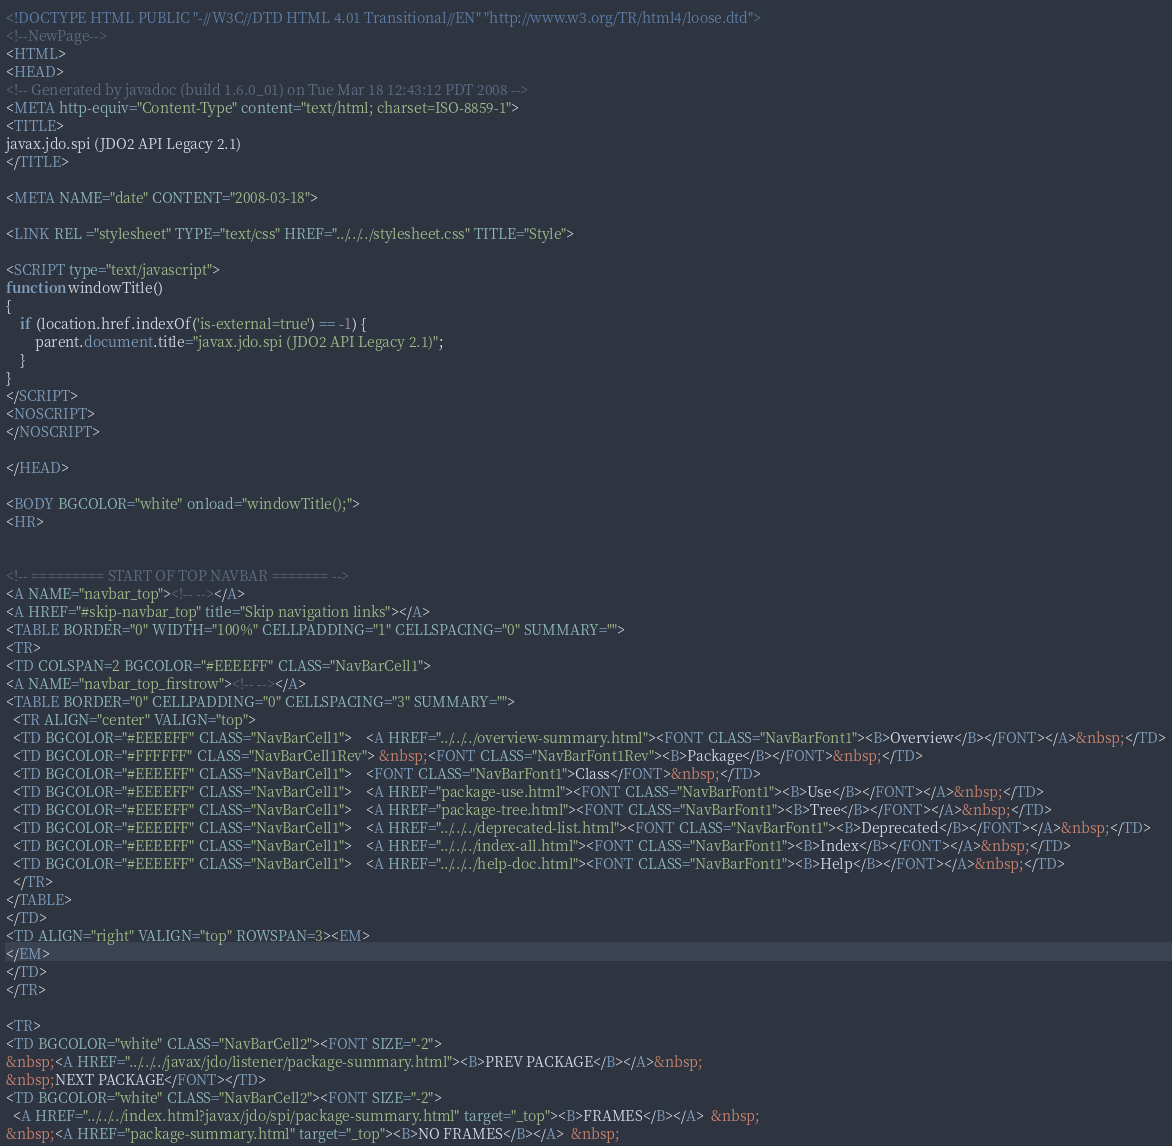Convert code to text. <code><loc_0><loc_0><loc_500><loc_500><_HTML_><!DOCTYPE HTML PUBLIC "-//W3C//DTD HTML 4.01 Transitional//EN" "http://www.w3.org/TR/html4/loose.dtd">
<!--NewPage-->
<HTML>
<HEAD>
<!-- Generated by javadoc (build 1.6.0_01) on Tue Mar 18 12:43:12 PDT 2008 -->
<META http-equiv="Content-Type" content="text/html; charset=ISO-8859-1">
<TITLE>
javax.jdo.spi (JDO2 API Legacy 2.1)
</TITLE>

<META NAME="date" CONTENT="2008-03-18">

<LINK REL ="stylesheet" TYPE="text/css" HREF="../../../stylesheet.css" TITLE="Style">

<SCRIPT type="text/javascript">
function windowTitle()
{
    if (location.href.indexOf('is-external=true') == -1) {
        parent.document.title="javax.jdo.spi (JDO2 API Legacy 2.1)";
    }
}
</SCRIPT>
<NOSCRIPT>
</NOSCRIPT>

</HEAD>

<BODY BGCOLOR="white" onload="windowTitle();">
<HR>


<!-- ========= START OF TOP NAVBAR ======= -->
<A NAME="navbar_top"><!-- --></A>
<A HREF="#skip-navbar_top" title="Skip navigation links"></A>
<TABLE BORDER="0" WIDTH="100%" CELLPADDING="1" CELLSPACING="0" SUMMARY="">
<TR>
<TD COLSPAN=2 BGCOLOR="#EEEEFF" CLASS="NavBarCell1">
<A NAME="navbar_top_firstrow"><!-- --></A>
<TABLE BORDER="0" CELLPADDING="0" CELLSPACING="3" SUMMARY="">
  <TR ALIGN="center" VALIGN="top">
  <TD BGCOLOR="#EEEEFF" CLASS="NavBarCell1">    <A HREF="../../../overview-summary.html"><FONT CLASS="NavBarFont1"><B>Overview</B></FONT></A>&nbsp;</TD>
  <TD BGCOLOR="#FFFFFF" CLASS="NavBarCell1Rev"> &nbsp;<FONT CLASS="NavBarFont1Rev"><B>Package</B></FONT>&nbsp;</TD>
  <TD BGCOLOR="#EEEEFF" CLASS="NavBarCell1">    <FONT CLASS="NavBarFont1">Class</FONT>&nbsp;</TD>
  <TD BGCOLOR="#EEEEFF" CLASS="NavBarCell1">    <A HREF="package-use.html"><FONT CLASS="NavBarFont1"><B>Use</B></FONT></A>&nbsp;</TD>
  <TD BGCOLOR="#EEEEFF" CLASS="NavBarCell1">    <A HREF="package-tree.html"><FONT CLASS="NavBarFont1"><B>Tree</B></FONT></A>&nbsp;</TD>
  <TD BGCOLOR="#EEEEFF" CLASS="NavBarCell1">    <A HREF="../../../deprecated-list.html"><FONT CLASS="NavBarFont1"><B>Deprecated</B></FONT></A>&nbsp;</TD>
  <TD BGCOLOR="#EEEEFF" CLASS="NavBarCell1">    <A HREF="../../../index-all.html"><FONT CLASS="NavBarFont1"><B>Index</B></FONT></A>&nbsp;</TD>
  <TD BGCOLOR="#EEEEFF" CLASS="NavBarCell1">    <A HREF="../../../help-doc.html"><FONT CLASS="NavBarFont1"><B>Help</B></FONT></A>&nbsp;</TD>
  </TR>
</TABLE>
</TD>
<TD ALIGN="right" VALIGN="top" ROWSPAN=3><EM>
</EM>
</TD>
</TR>

<TR>
<TD BGCOLOR="white" CLASS="NavBarCell2"><FONT SIZE="-2">
&nbsp;<A HREF="../../../javax/jdo/listener/package-summary.html"><B>PREV PACKAGE</B></A>&nbsp;
&nbsp;NEXT PACKAGE</FONT></TD>
<TD BGCOLOR="white" CLASS="NavBarCell2"><FONT SIZE="-2">
  <A HREF="../../../index.html?javax/jdo/spi/package-summary.html" target="_top"><B>FRAMES</B></A>  &nbsp;
&nbsp;<A HREF="package-summary.html" target="_top"><B>NO FRAMES</B></A>  &nbsp;</code> 